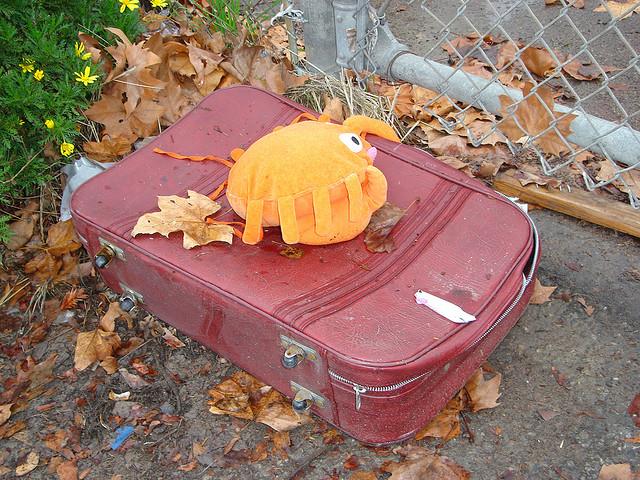What is the color of the suitcase?
Give a very brief answer. Red. What color is the suitcase?
Keep it brief. Red. How many flowers in the picture?
Answer briefly. 8. 